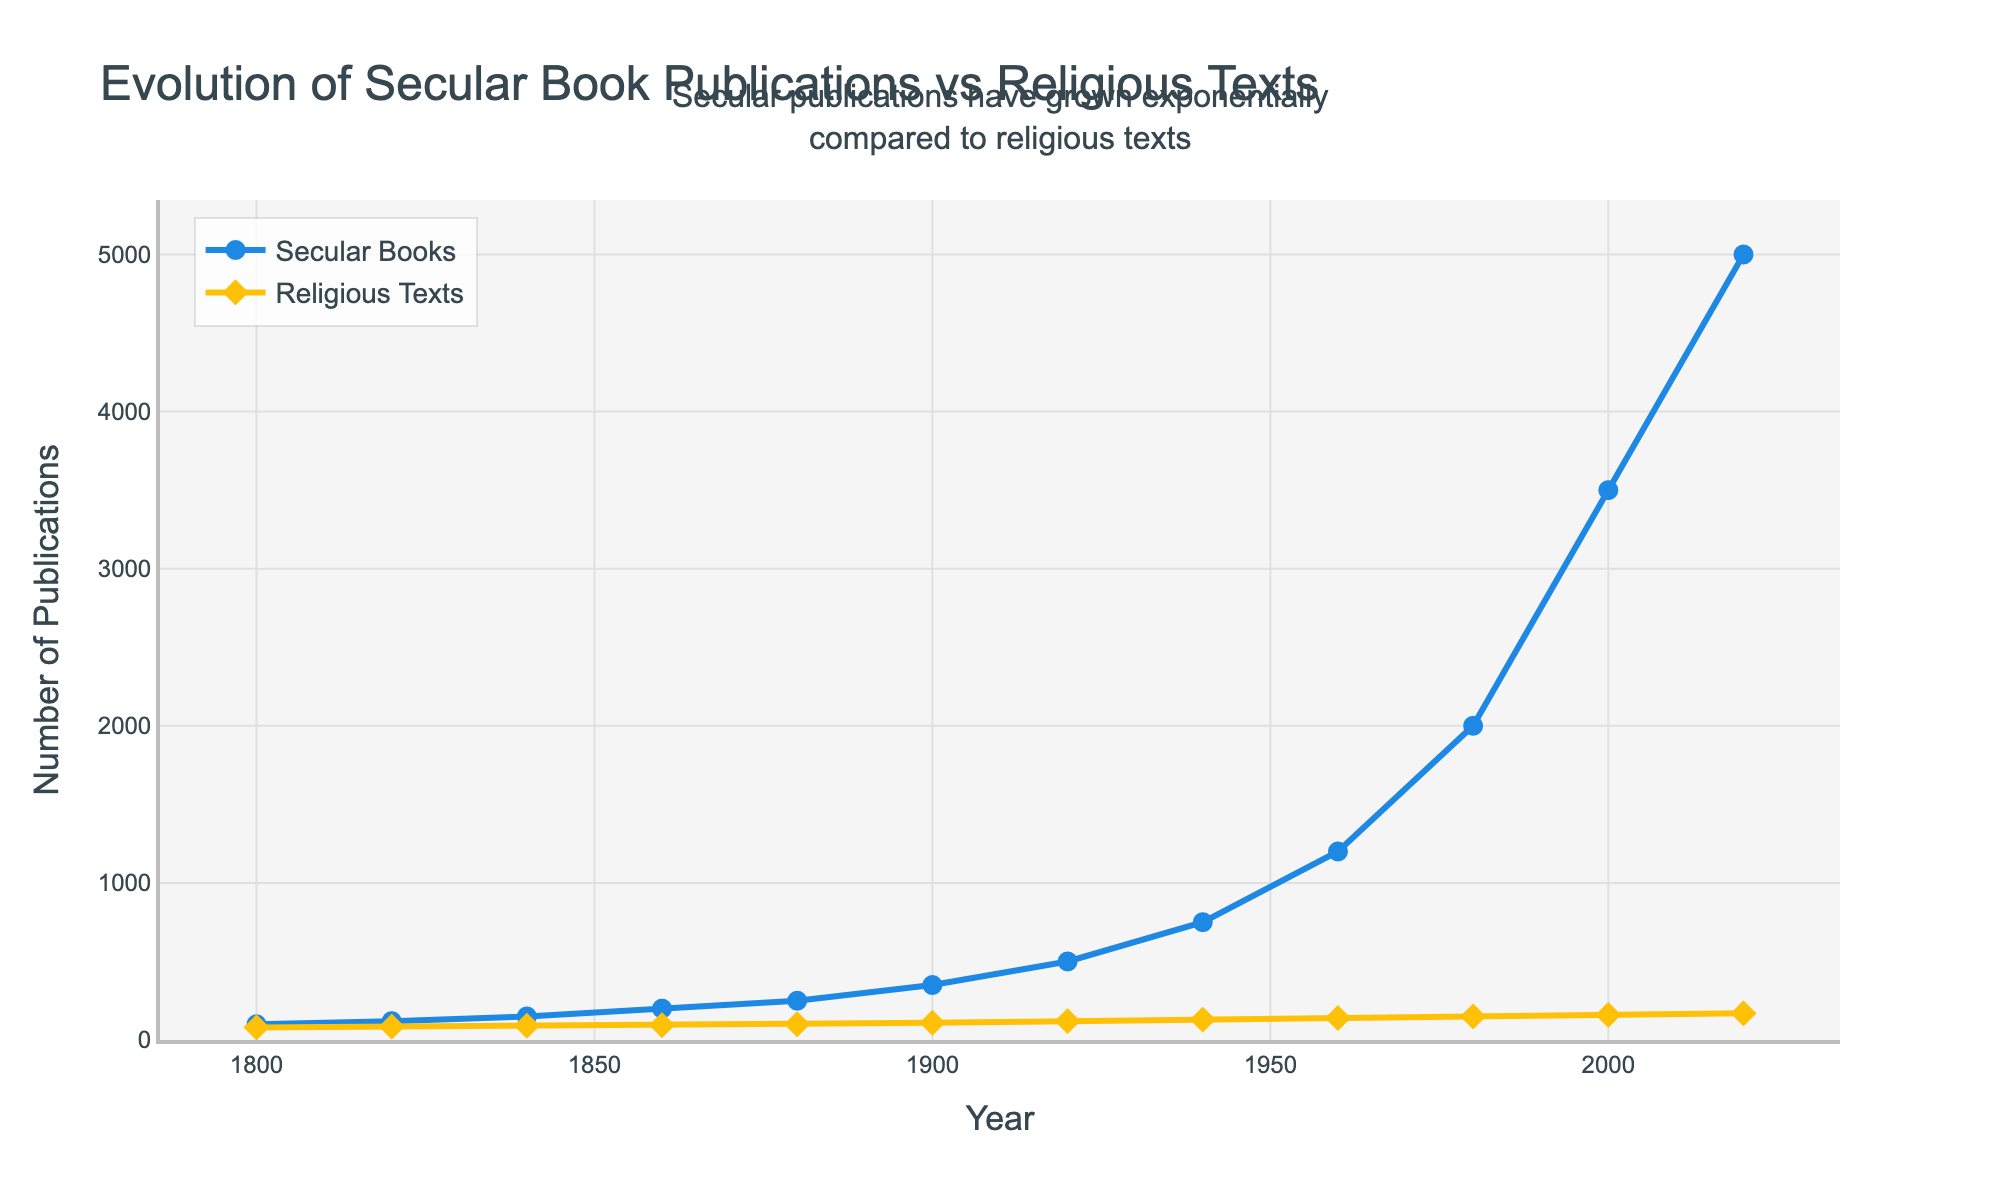What trend do you observe in the publication of secular books from 1800 to 2020? The publication of secular books shows a steady increase from 100 in 1800 to 5000 in 2020, with notable accelerations after 1900 and 1960.
Answer: Steady increase, with accelerations after 1900 and 1960 Which year shows the highest number of published religious texts? By examining the chart, the highest number of published religious texts is observed in the year 2020, where the number is 170.
Answer: 2020 By how much did the publication of secular books increase between 1800 and 2000? The number of secular books published in 1800 was 100, and in 2000 it was 3500. The increase is calculated as 3500 - 100.
Answer: 3400 What is the difference in the number of published secular books and religious texts in 1960? In 1960, the number of secular books published is 1200 and religious texts published is 140. The difference is 1200 - 140.
Answer: 1060 Compare the growth rate of secular books and religious texts between 1900 and 1920. Secular books increased from 350 in 1900 to 500 in 1920, and religious texts increased from 110 to 120. The growth for secular books is (500 - 350)/350 = 0.428 or 42.8%, and for religious texts, it is (120 - 110)/110 = 0.0909 or 9.09%.
Answer: Secular books: 42.8%, Religious texts: 9.09% How many more secular books were published than religious texts in 1940? From the chart, in 1940, 750 secular books and 130 religious texts were published. The difference is 750 - 130.
Answer: 620 What is the average number of secular books published per year in the 20th century (1900-2000)? The number of secular books published in the 20th century at the given data points (1900, 1920, 1940, 1960, 1980, 2000) are 350, 500, 750, 1200, 2000, and 3500. The average is (350 + 500 + 750 + 1200 + 2000 + 3500)/6.
Answer: 1383.33 Between which consecutive years did the publication of secular books see the largest increase? By examining the differences in the number of secular books between consecutive years: 
    - 1800 to 1820: 120 - 100 = 20 
    - 1820 to 1840: 150 - 120 = 30 
    - 1840 to 1860: 200 - 150 = 50 
    - 1860 to 1880: 250 - 200 = 50 
    - 1880 to 1900: 350 - 250 = 100 
    - 1900 to 1920: 500 - 350 = 150 
    - 1920 to 1940: 750 - 500 = 250 
    - 1940 to 1960: 1200 - 750 = 450 
    - 1960 to 1980: 2000 - 1200 = 800 
    - 1980 to 2000: 3500 - 2000 = 1500 
    - 2000 to 2020: 5000 - 3500 = 1500
The largest increases are from 1980 to 2000 and 2000 to 2020, both showing an increase of 1500.
Answer: 1980 to 2000 and 2000 to 2020 